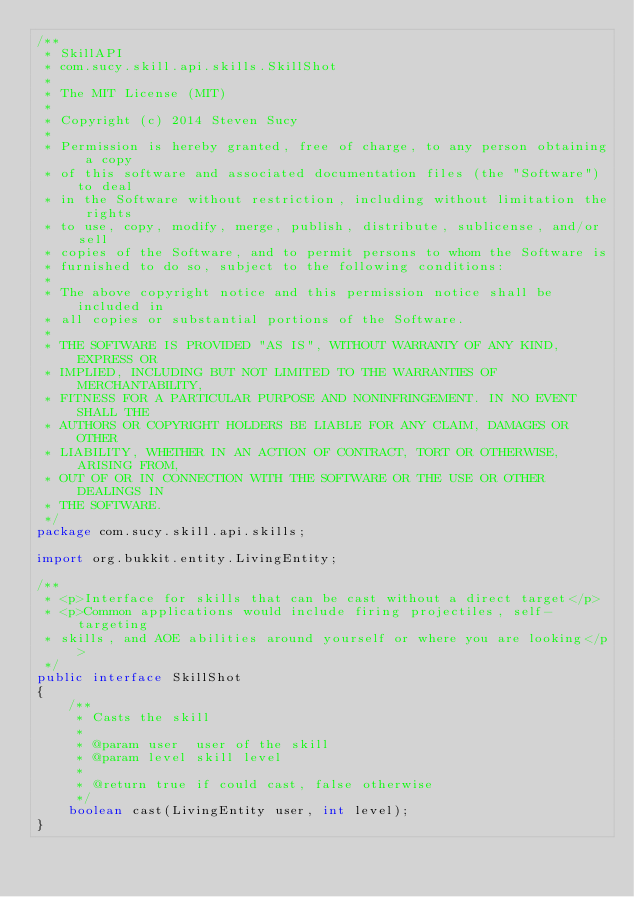<code> <loc_0><loc_0><loc_500><loc_500><_Java_>/**
 * SkillAPI
 * com.sucy.skill.api.skills.SkillShot
 *
 * The MIT License (MIT)
 *
 * Copyright (c) 2014 Steven Sucy
 *
 * Permission is hereby granted, free of charge, to any person obtaining a copy
 * of this software and associated documentation files (the "Software") to deal
 * in the Software without restriction, including without limitation the rights
 * to use, copy, modify, merge, publish, distribute, sublicense, and/or sell
 * copies of the Software, and to permit persons to whom the Software is
 * furnished to do so, subject to the following conditions:
 *
 * The above copyright notice and this permission notice shall be included in
 * all copies or substantial portions of the Software.
 *
 * THE SOFTWARE IS PROVIDED "AS IS", WITHOUT WARRANTY OF ANY KIND, EXPRESS OR
 * IMPLIED, INCLUDING BUT NOT LIMITED TO THE WARRANTIES OF MERCHANTABILITY,
 * FITNESS FOR A PARTICULAR PURPOSE AND NONINFRINGEMENT. IN NO EVENT SHALL THE
 * AUTHORS OR COPYRIGHT HOLDERS BE LIABLE FOR ANY CLAIM, DAMAGES OR OTHER
 * LIABILITY, WHETHER IN AN ACTION OF CONTRACT, TORT OR OTHERWISE, ARISING FROM,
 * OUT OF OR IN CONNECTION WITH THE SOFTWARE OR THE USE OR OTHER DEALINGS IN
 * THE SOFTWARE.
 */
package com.sucy.skill.api.skills;

import org.bukkit.entity.LivingEntity;

/**
 * <p>Interface for skills that can be cast without a direct target</p>
 * <p>Common applications would include firing projectiles, self-targeting
 * skills, and AOE abilities around yourself or where you are looking</p>
 */
public interface SkillShot
{
    /**
     * Casts the skill
     *
     * @param user  user of the skill
     * @param level skill level
     *
     * @return true if could cast, false otherwise
     */
    boolean cast(LivingEntity user, int level);
}
</code> 